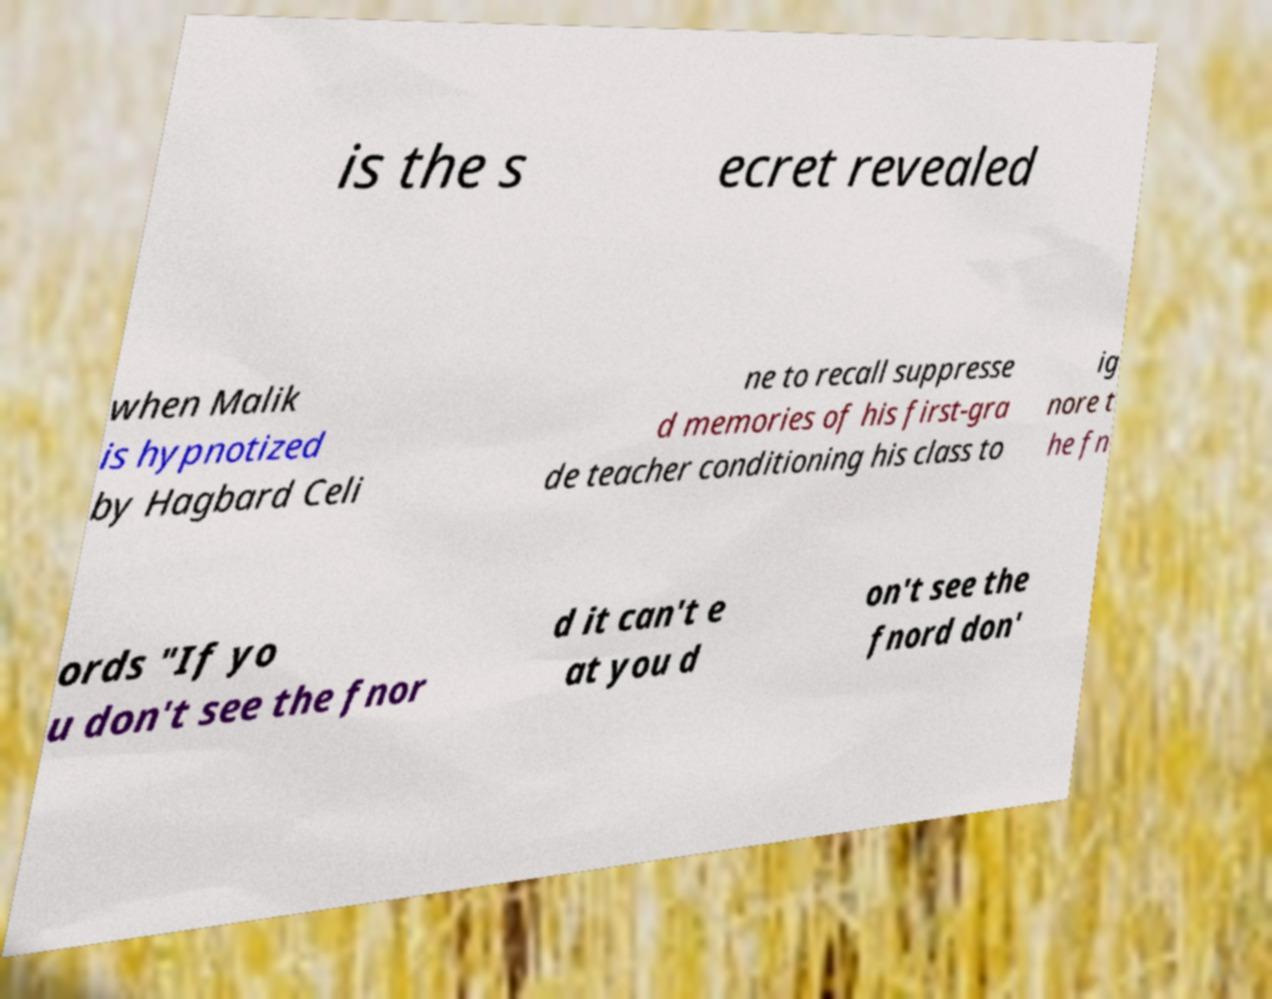What messages or text are displayed in this image? I need them in a readable, typed format. is the s ecret revealed when Malik is hypnotized by Hagbard Celi ne to recall suppresse d memories of his first-gra de teacher conditioning his class to ig nore t he fn ords "If yo u don't see the fnor d it can't e at you d on't see the fnord don' 